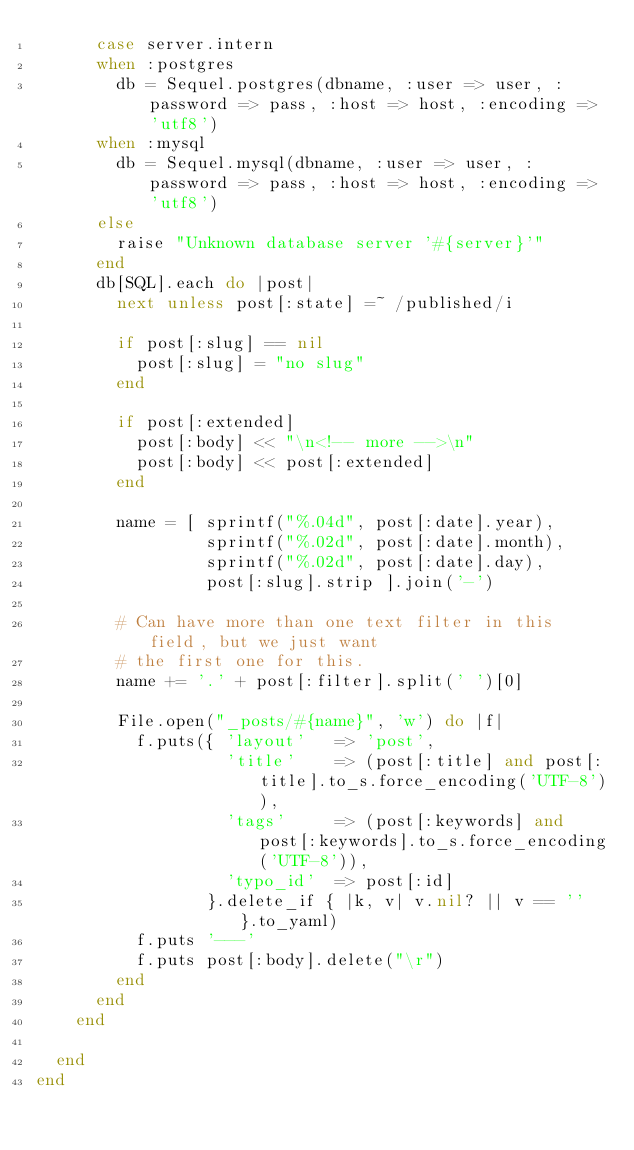Convert code to text. <code><loc_0><loc_0><loc_500><loc_500><_Ruby_>      case server.intern
      when :postgres
        db = Sequel.postgres(dbname, :user => user, :password => pass, :host => host, :encoding => 'utf8')
      when :mysql
        db = Sequel.mysql(dbname, :user => user, :password => pass, :host => host, :encoding => 'utf8')
      else
        raise "Unknown database server '#{server}'"
      end
      db[SQL].each do |post|
        next unless post[:state] =~ /published/i

        if post[:slug] == nil
          post[:slug] = "no slug"
        end

        if post[:extended]
          post[:body] << "\n<!-- more -->\n"
          post[:body] << post[:extended]
        end

        name = [ sprintf("%.04d", post[:date].year),
                 sprintf("%.02d", post[:date].month),
                 sprintf("%.02d", post[:date].day),
                 post[:slug].strip ].join('-')

        # Can have more than one text filter in this field, but we just want
        # the first one for this.
        name += '.' + post[:filter].split(' ')[0]

        File.open("_posts/#{name}", 'w') do |f|
          f.puts({ 'layout'   => 'post',
                   'title'    => (post[:title] and post[:title].to_s.force_encoding('UTF-8')),
                   'tags'     => (post[:keywords] and post[:keywords].to_s.force_encoding('UTF-8')),
                   'typo_id'  => post[:id]
                 }.delete_if { |k, v| v.nil? || v == '' }.to_yaml)
          f.puts '---'
          f.puts post[:body].delete("\r")
        end
      end
    end

  end
end
</code> 